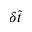<formula> <loc_0><loc_0><loc_500><loc_500>\delta \tilde { t }</formula> 